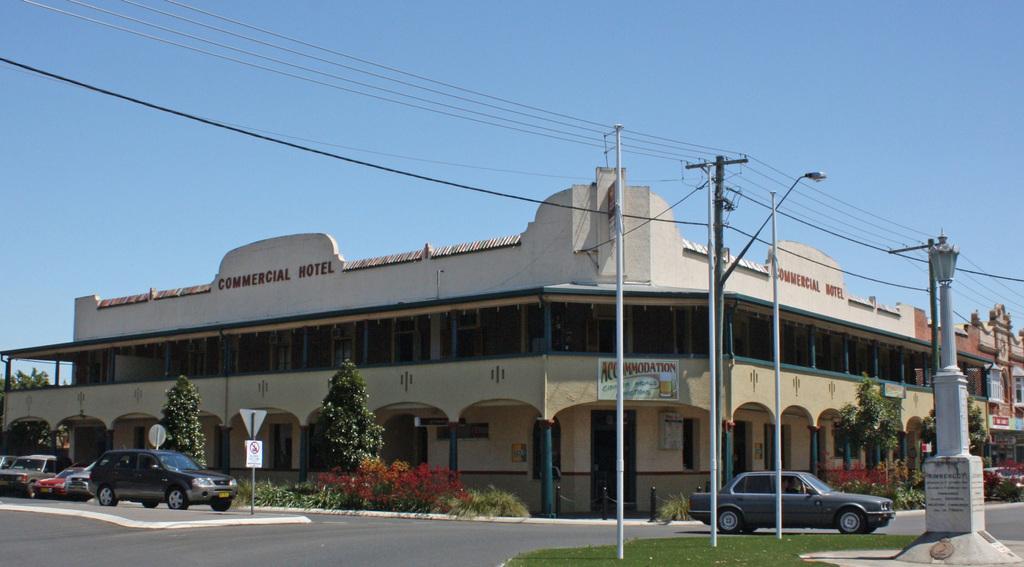In one or two sentences, can you explain what this image depicts? There are vehicles, trees and some moles are present at the bottom of this image, and there is a building in the background. There is a sky at the top of this image. 